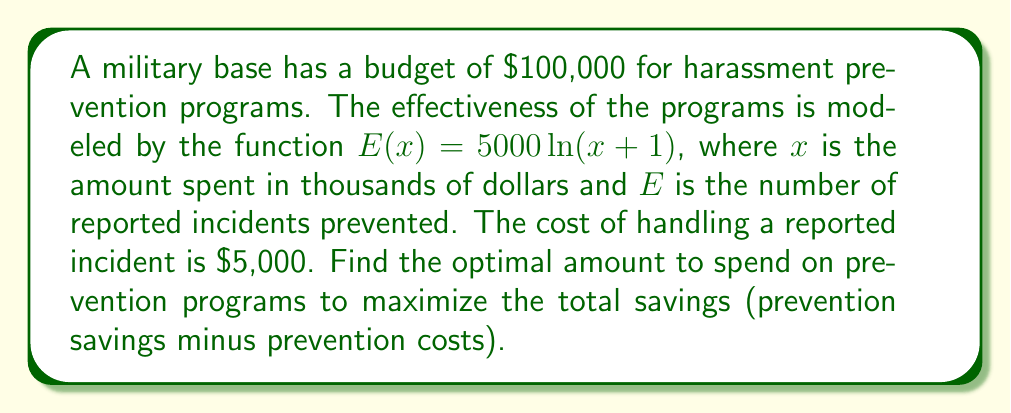Help me with this question. 1) Let's define the savings function $S(x)$:
   $S(x) = 5000E(x) - 1000x$
   where $5000E(x)$ is the money saved from prevented incidents, and $1000x$ is the cost of prevention programs in dollars.

2) Substitute the given $E(x)$:
   $S(x) = 5000(5000\ln(x+1)) - 1000x$
   $S(x) = 25,000,000\ln(x+1) - 1000x$

3) To find the maximum savings, we need to find where $\frac{dS}{dx} = 0$:
   $$\frac{dS}{dx} = \frac{25,000,000}{x+1} - 1000$$

4) Set this equal to 0 and solve:
   $$\frac{25,000,000}{x+1} - 1000 = 0$$
   $$\frac{25,000,000}{x+1} = 1000$$
   $$25,000,000 = 1000(x+1)$$
   $$25,000 = x+1$$
   $$x = 24,999$$

5) The second derivative is negative, confirming this is a maximum:
   $$\frac{d^2S}{dx^2} = -\frac{25,000,000}{(x+1)^2} < 0$$

6) Since $x$ is in thousands of dollars, the optimal spending is $24,999,000.

7) However, given the budget constraint of $100,000, the optimal amount to spend is the full budget.
Answer: $100,000 